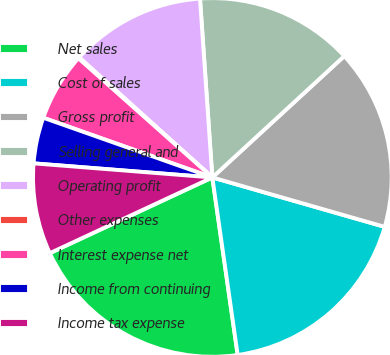Convert chart. <chart><loc_0><loc_0><loc_500><loc_500><pie_chart><fcel>Net sales<fcel>Cost of sales<fcel>Gross profit<fcel>Selling general and<fcel>Operating profit<fcel>Other expenses<fcel>Interest expense net<fcel>Income from continuing<fcel>Income tax expense<nl><fcel>20.32%<fcel>18.3%<fcel>16.28%<fcel>14.26%<fcel>12.23%<fcel>0.1%<fcel>6.17%<fcel>4.15%<fcel>8.19%<nl></chart> 